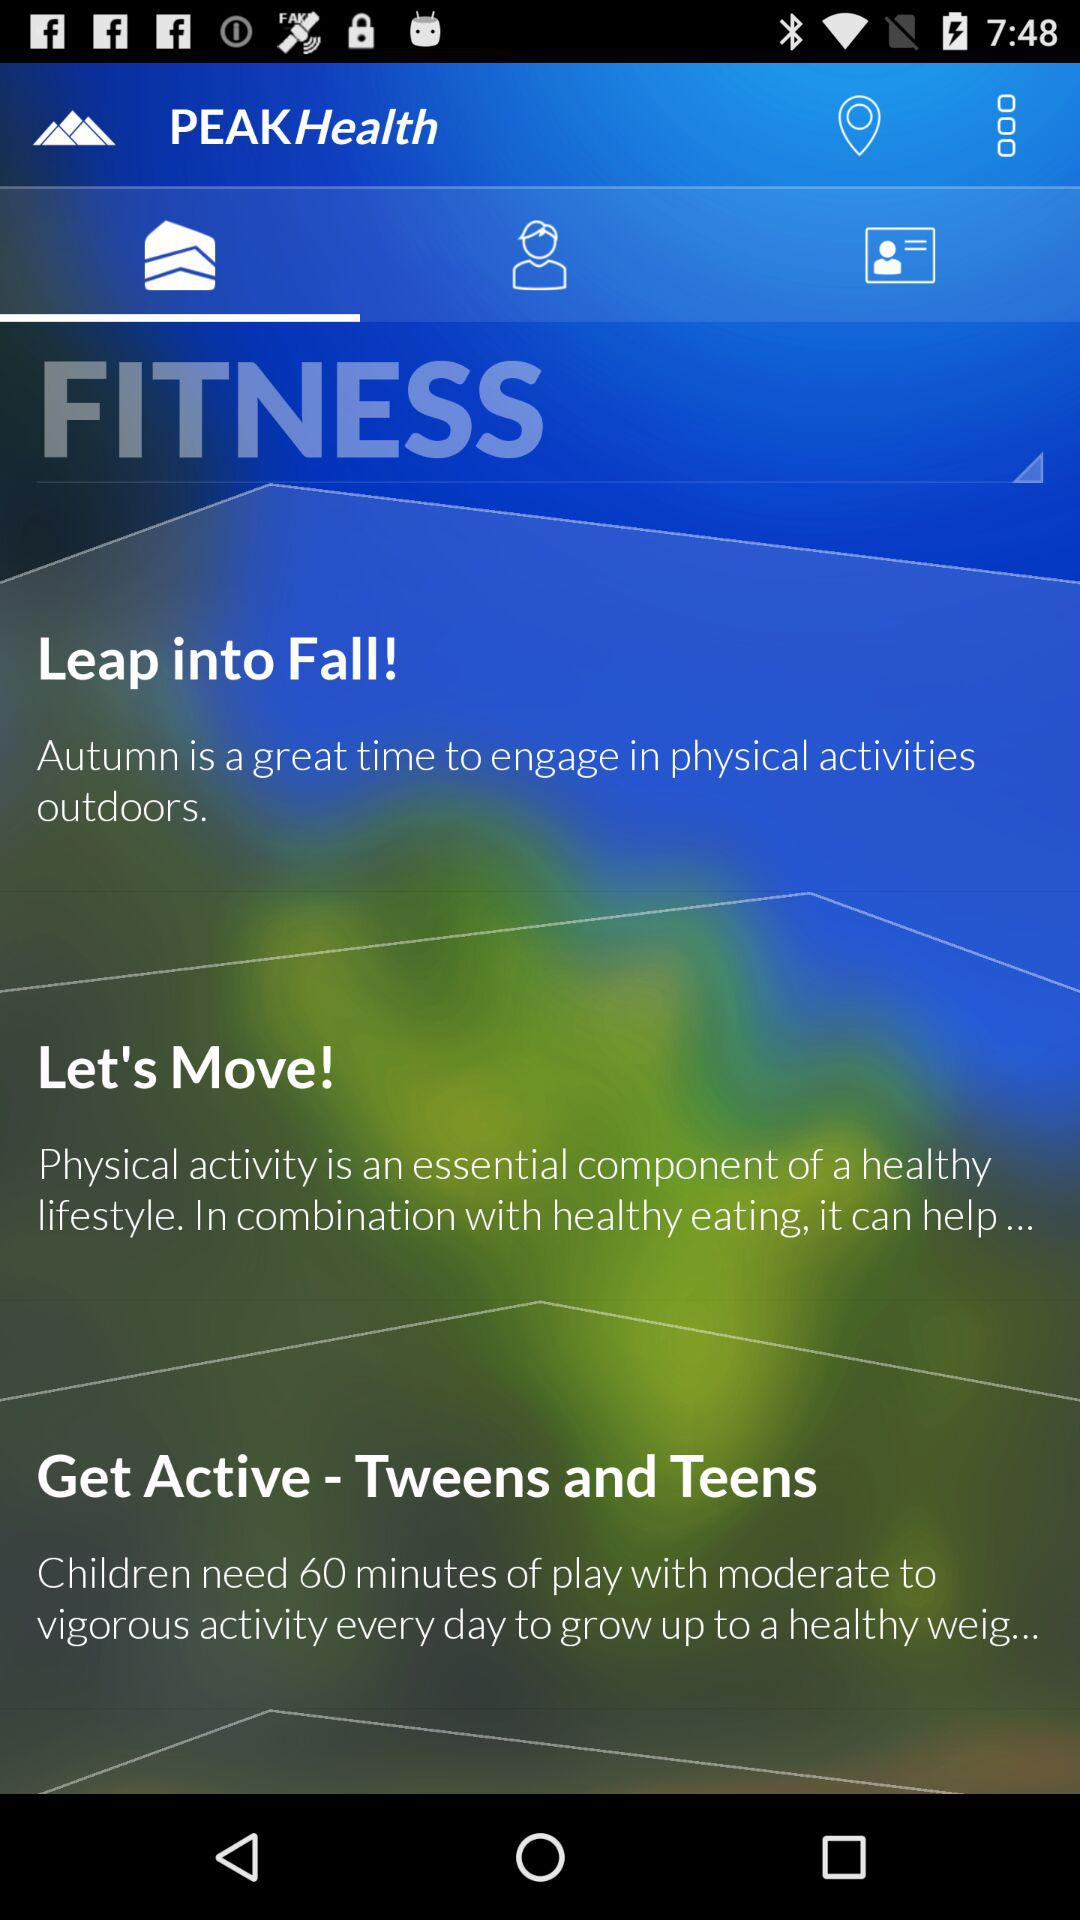What is the application name? The application name is "PEAKHealth". 